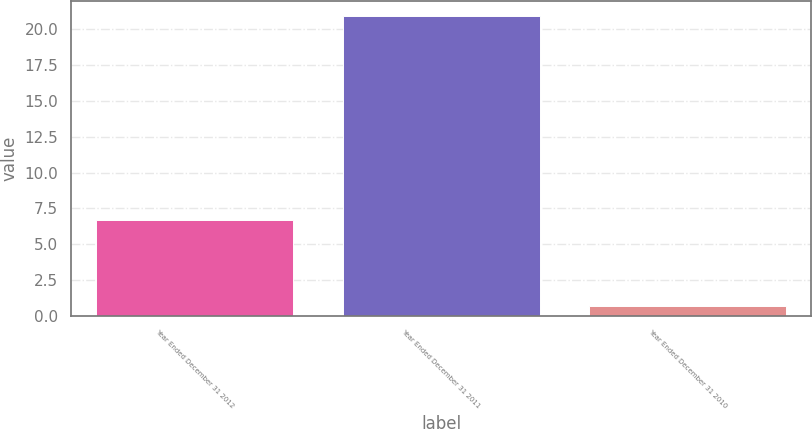Convert chart. <chart><loc_0><loc_0><loc_500><loc_500><bar_chart><fcel>Year Ended December 31 2012<fcel>Year Ended December 31 2011<fcel>Year Ended December 31 2010<nl><fcel>6.7<fcel>20.9<fcel>0.7<nl></chart> 